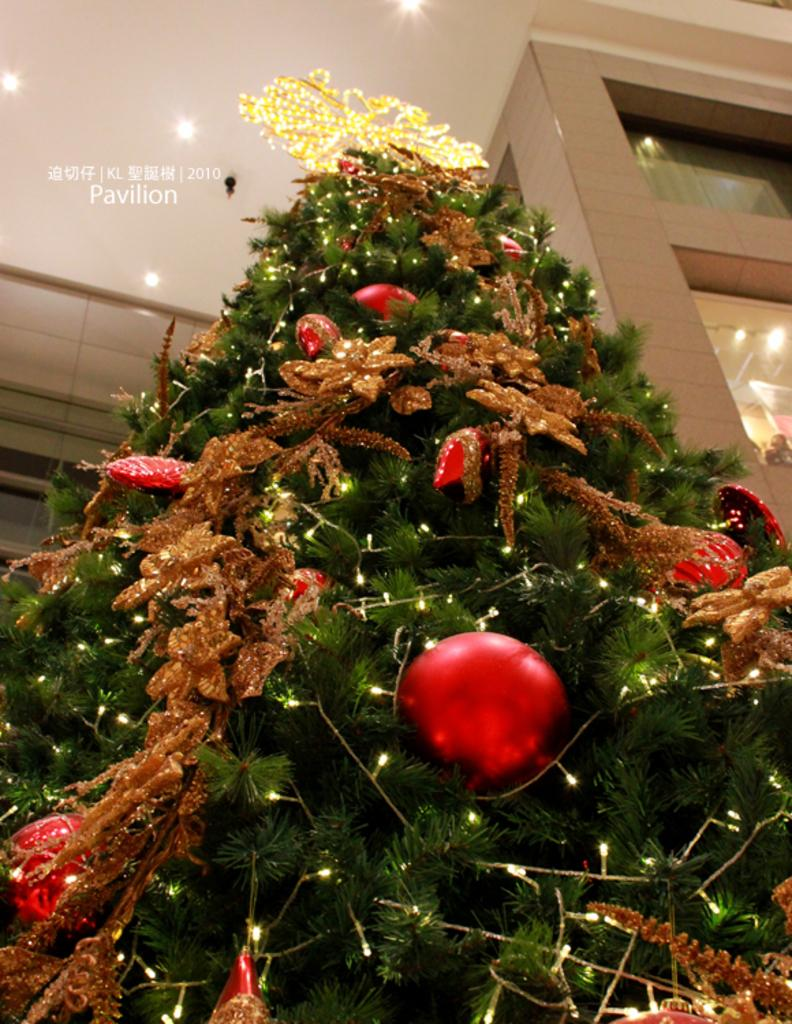What is the main subject in the middle of the picture? There is a Christmas tree in the middle of the picture. What can be seen in the background of the picture? There is a ceiling visible in the background of the picture. What type of bird is perched on the Christmas tree in the image? There are no birds present in the image; it only features a Christmas tree and a ceiling in the background. 